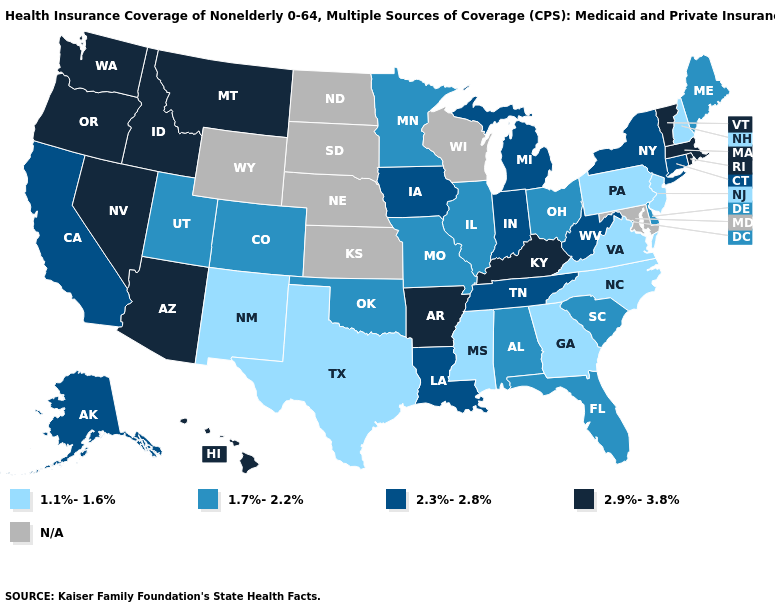Among the states that border Michigan , does Ohio have the highest value?
Be succinct. No. What is the highest value in states that border Missouri?
Answer briefly. 2.9%-3.8%. Which states hav the highest value in the Northeast?
Be succinct. Massachusetts, Rhode Island, Vermont. What is the value of Louisiana?
Keep it brief. 2.3%-2.8%. Among the states that border West Virginia , does Kentucky have the lowest value?
Short answer required. No. What is the value of Washington?
Short answer required. 2.9%-3.8%. What is the value of Wyoming?
Write a very short answer. N/A. What is the value of Florida?
Short answer required. 1.7%-2.2%. Does Rhode Island have the highest value in the USA?
Concise answer only. Yes. Does New Mexico have the lowest value in the West?
Write a very short answer. Yes. What is the highest value in the USA?
Short answer required. 2.9%-3.8%. What is the highest value in the MidWest ?
Keep it brief. 2.3%-2.8%. Does the map have missing data?
Give a very brief answer. Yes. Among the states that border Connecticut , which have the lowest value?
Be succinct. New York. 